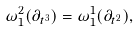Convert formula to latex. <formula><loc_0><loc_0><loc_500><loc_500>\omega ^ { 2 } _ { 1 } ( \partial _ { t ^ { 3 } } ) = \omega ^ { 1 } _ { 1 } ( \partial _ { t ^ { 2 } } ) ,</formula> 